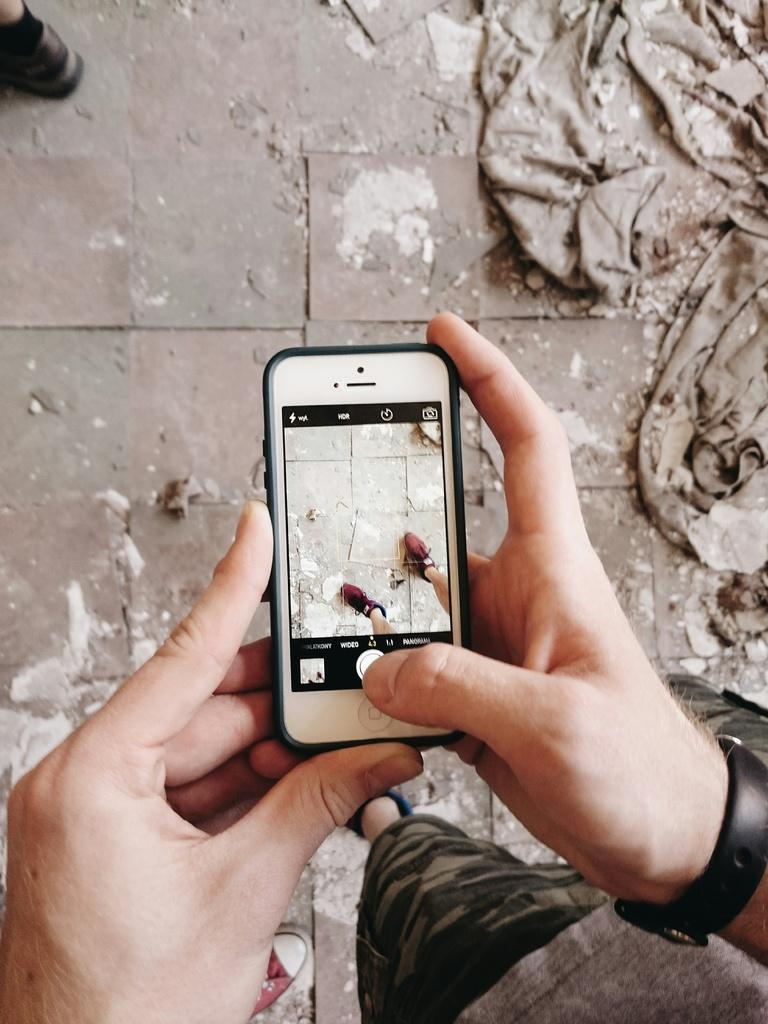What can be seen at the bottom of the image? The floor is visible at the bottom portion of the image. What part of a person's body is present in the image? A person's leg is present in the image. What type of object is in the image? There is a cloth in the image. What accessory is the person wearing in the image? The person is wearing a wristwatch in the image. What is the person holding in the image? The person is holding a camera in the image. What action is the person performing in the image? The person is taking a snapshot in the image. What is the dirt condition of the person's shoes in the image? There is no information about the dirt condition of the person's shoes in the image. What is the position of the person's elbow in the image? The position of the person's elbow is not mentioned in the provided facts, so it cannot be determined from the image. 